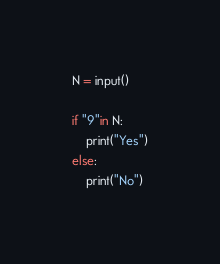Convert code to text. <code><loc_0><loc_0><loc_500><loc_500><_Python_>N = input()

if "9"in N:
    print("Yes")
else:
    print("No")</code> 